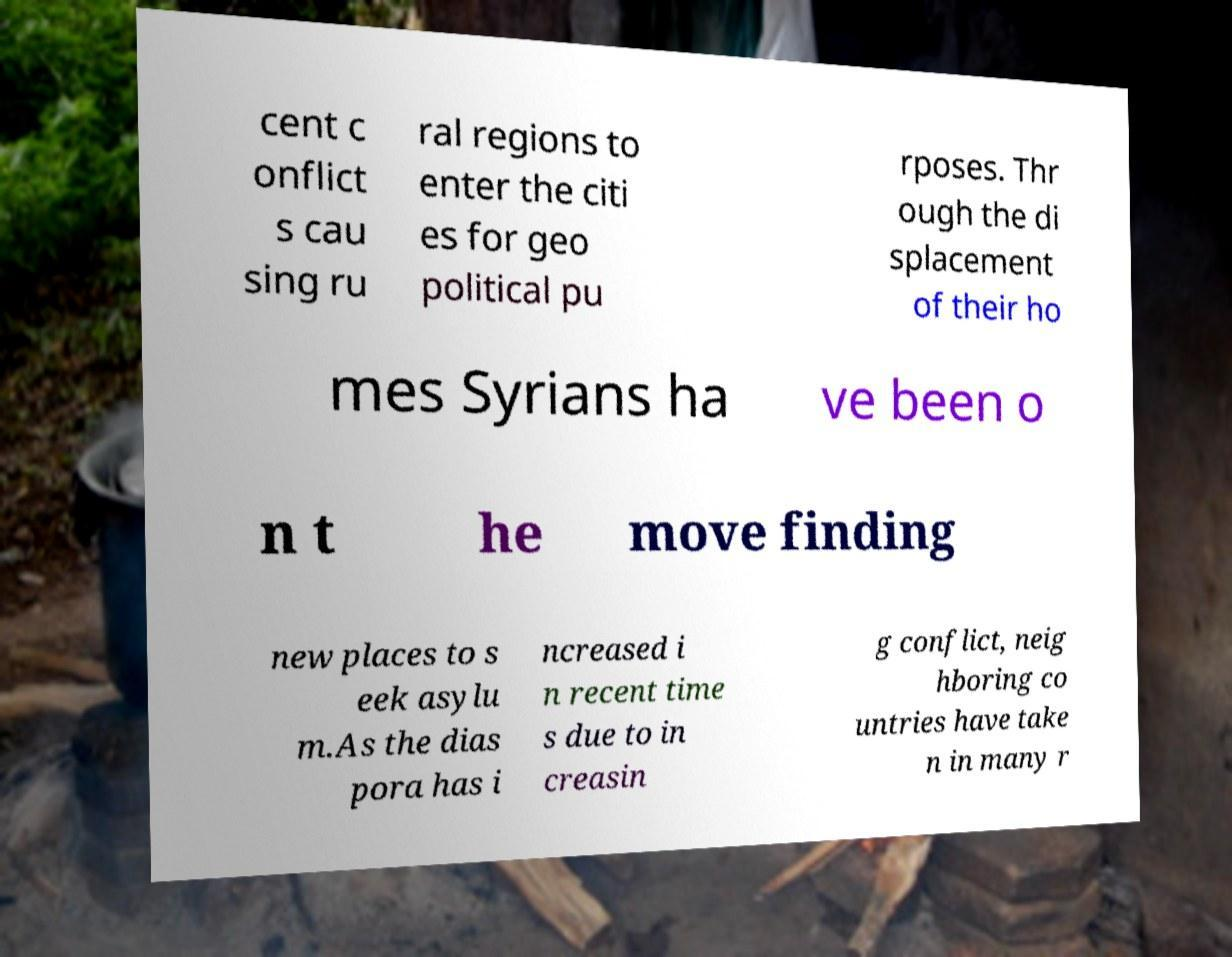I need the written content from this picture converted into text. Can you do that? cent c onflict s cau sing ru ral regions to enter the citi es for geo political pu rposes. Thr ough the di splacement of their ho mes Syrians ha ve been o n t he move finding new places to s eek asylu m.As the dias pora has i ncreased i n recent time s due to in creasin g conflict, neig hboring co untries have take n in many r 